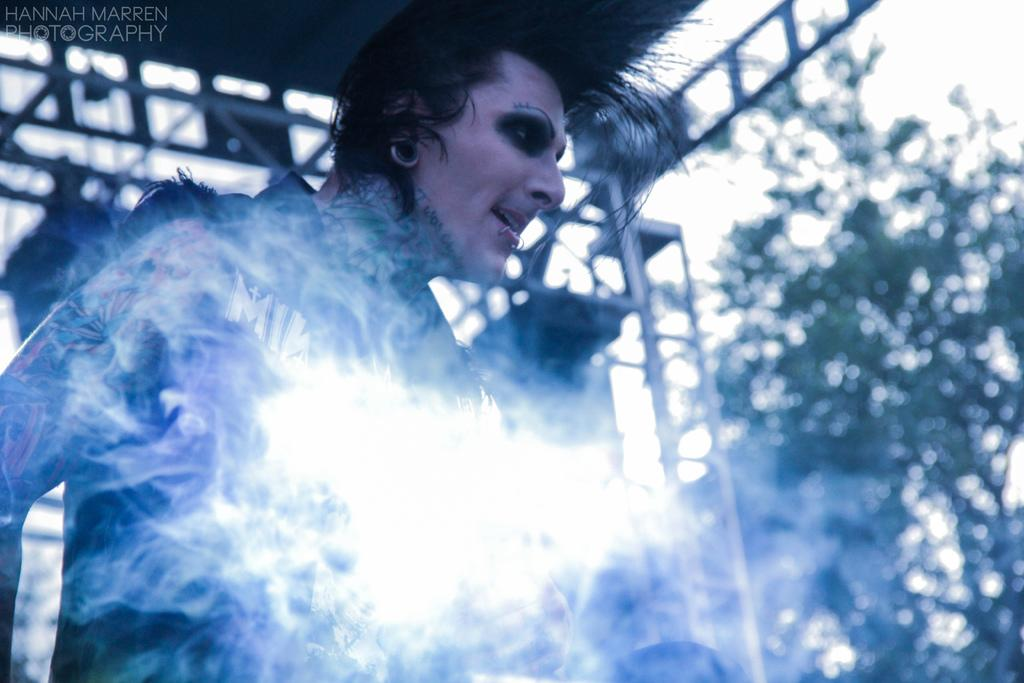Who or what is present in the image? There is a person in the image. What type of vegetation can be seen on the right side of the image? There are trees on the right side of the image. What is present in the top left corner of the image? There is a watermark in the top left corner of the image. What can be seen in the background of the image? The sky is visible in the background of the image. What type of jewel is the person wearing on their neck in the image? There is no jewel visible on the person's neck in the image. How many clams can be seen on the ground near the person in the image? There are no clams present in the image. 